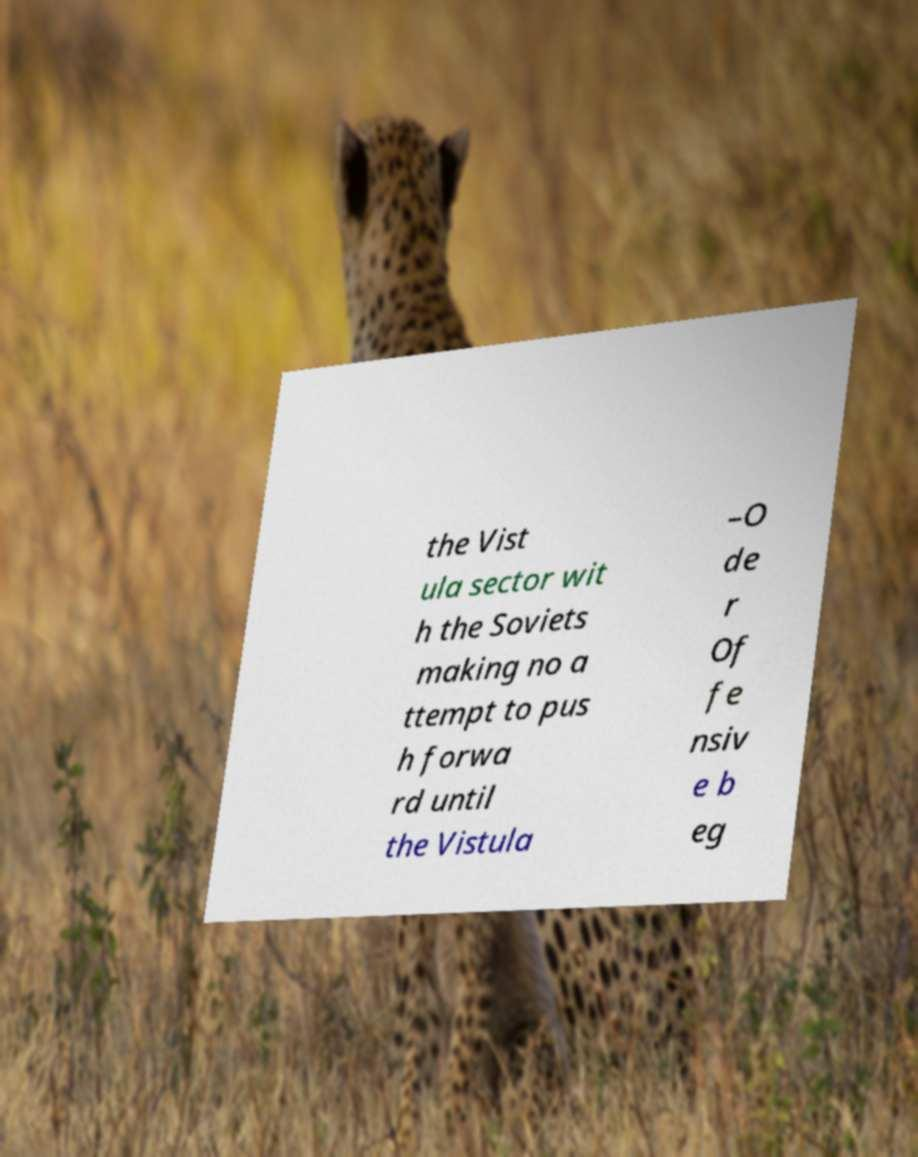Please read and relay the text visible in this image. What does it say? the Vist ula sector wit h the Soviets making no a ttempt to pus h forwa rd until the Vistula –O de r Of fe nsiv e b eg 